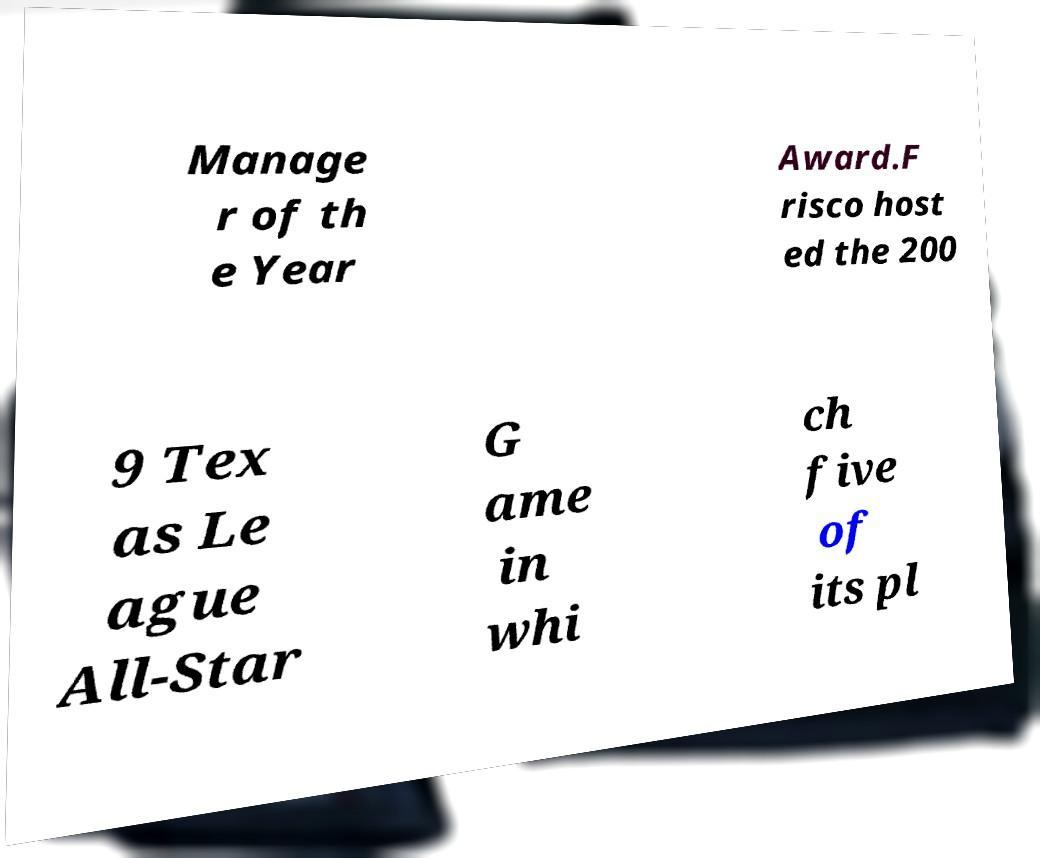What messages or text are displayed in this image? I need them in a readable, typed format. Manage r of th e Year Award.F risco host ed the 200 9 Tex as Le ague All-Star G ame in whi ch five of its pl 